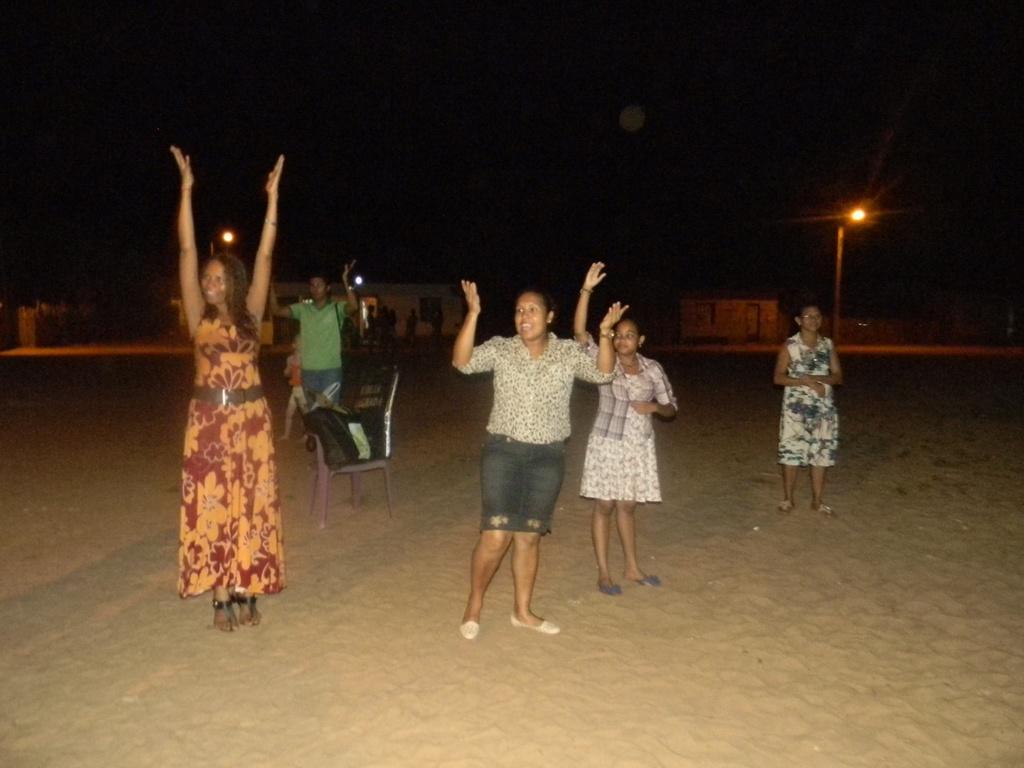Could you give a brief overview of what you see in this image? In this image we can see some group of persons standing on the ground and raising their hands up, there is chair on which there is bag and at the background of the image there are some houses, street lights and dark sky. 